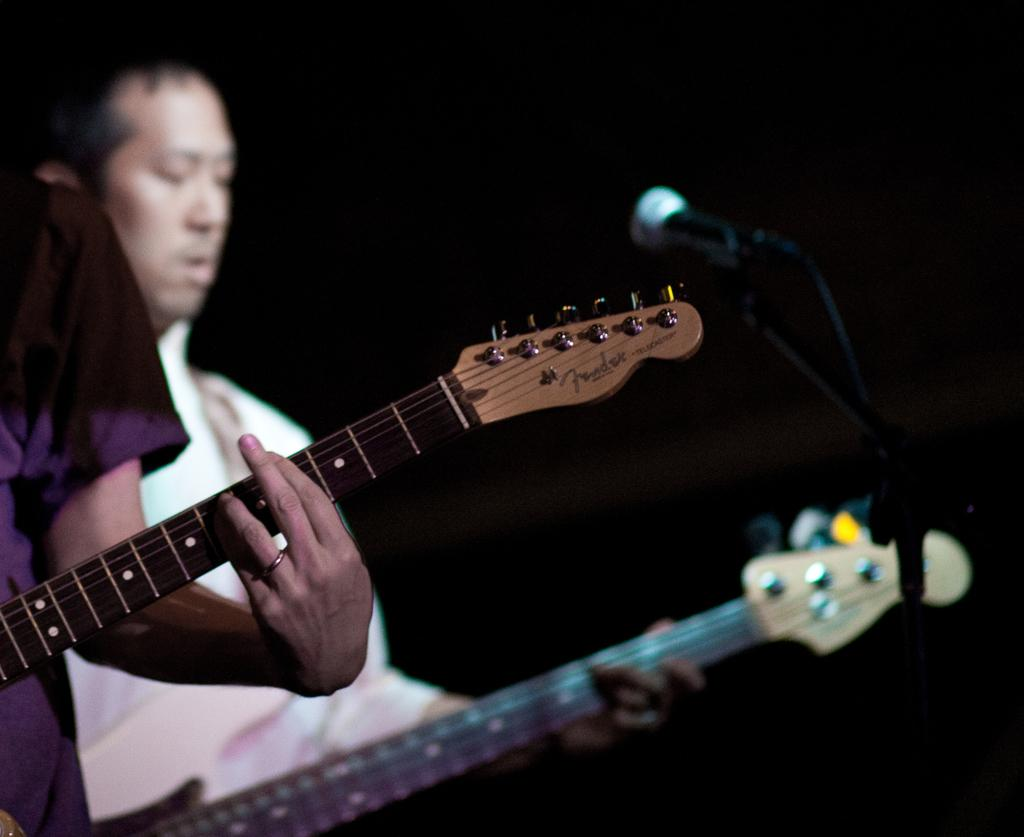What is the main subject of the image? There is a person in the image. What is the person doing in the image? The person is standing and holding a guitar in their hand. Can you describe the quality of the image? The image is blurry. How many babies are visible in the image? There are no babies present in the image. What type of stocking is the person wearing in the image? There is no mention of stockings in the image, and the person's clothing is not visible due to the blurry quality. 